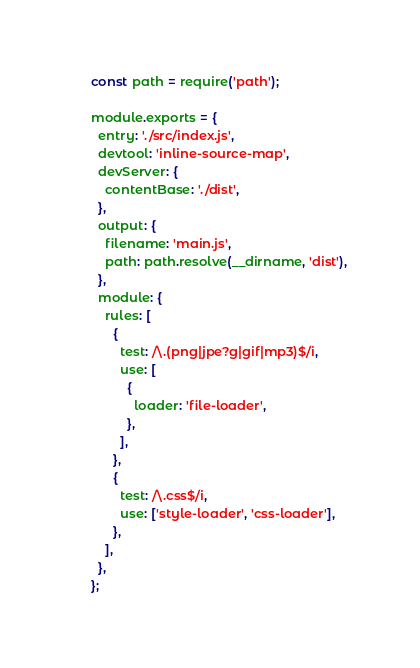<code> <loc_0><loc_0><loc_500><loc_500><_JavaScript_>const path = require('path');

module.exports = {
  entry: './src/index.js',
  devtool: 'inline-source-map',
  devServer: {
    contentBase: './dist',
  },
  output: {
    filename: 'main.js',
    path: path.resolve(__dirname, 'dist'),
  },
  module: {
    rules: [
      {
        test: /\.(png|jpe?g|gif|mp3)$/i,
        use: [
          {
            loader: 'file-loader',
          },
        ],
      },
      {
        test: /\.css$/i,
        use: ['style-loader', 'css-loader'],
      },
    ],
  },
};</code> 